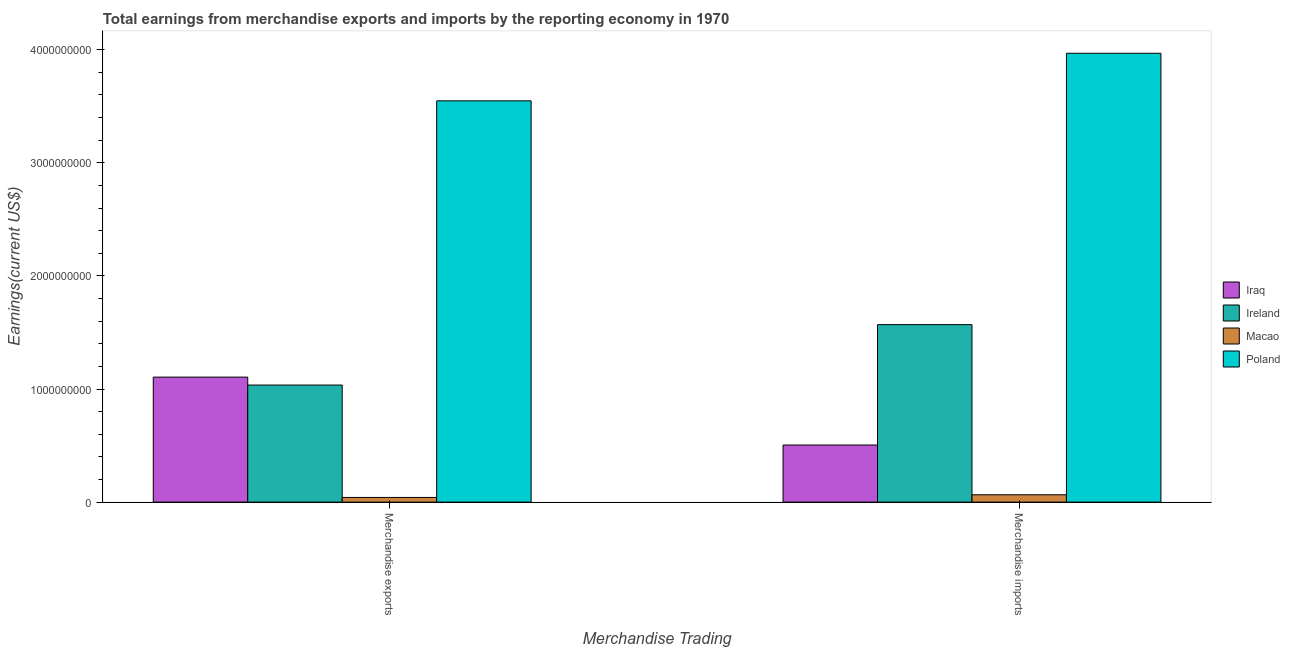How many different coloured bars are there?
Your answer should be compact. 4. How many groups of bars are there?
Ensure brevity in your answer.  2. Are the number of bars per tick equal to the number of legend labels?
Your response must be concise. Yes. Are the number of bars on each tick of the X-axis equal?
Make the answer very short. Yes. How many bars are there on the 1st tick from the left?
Your response must be concise. 4. What is the label of the 1st group of bars from the left?
Keep it short and to the point. Merchandise exports. What is the earnings from merchandise imports in Iraq?
Give a very brief answer. 5.05e+08. Across all countries, what is the maximum earnings from merchandise exports?
Your response must be concise. 3.55e+09. Across all countries, what is the minimum earnings from merchandise imports?
Provide a short and direct response. 6.50e+07. In which country was the earnings from merchandise imports maximum?
Make the answer very short. Poland. In which country was the earnings from merchandise imports minimum?
Give a very brief answer. Macao. What is the total earnings from merchandise imports in the graph?
Your answer should be compact. 6.11e+09. What is the difference between the earnings from merchandise imports in Ireland and that in Iraq?
Provide a short and direct response. 1.06e+09. What is the difference between the earnings from merchandise imports in Iraq and the earnings from merchandise exports in Poland?
Make the answer very short. -3.04e+09. What is the average earnings from merchandise exports per country?
Your answer should be very brief. 1.43e+09. What is the difference between the earnings from merchandise imports and earnings from merchandise exports in Poland?
Give a very brief answer. 4.21e+08. What is the ratio of the earnings from merchandise imports in Poland to that in Ireland?
Offer a terse response. 2.53. Is the earnings from merchandise imports in Macao less than that in Poland?
Keep it short and to the point. Yes. What does the 3rd bar from the left in Merchandise exports represents?
Make the answer very short. Macao. What does the 1st bar from the right in Merchandise exports represents?
Provide a succinct answer. Poland. How many bars are there?
Make the answer very short. 8. Are all the bars in the graph horizontal?
Offer a very short reply. No. How many countries are there in the graph?
Make the answer very short. 4. What is the difference between two consecutive major ticks on the Y-axis?
Offer a very short reply. 1.00e+09. Where does the legend appear in the graph?
Offer a terse response. Center right. How are the legend labels stacked?
Your answer should be very brief. Vertical. What is the title of the graph?
Your answer should be very brief. Total earnings from merchandise exports and imports by the reporting economy in 1970. Does "Indonesia" appear as one of the legend labels in the graph?
Provide a short and direct response. No. What is the label or title of the X-axis?
Offer a very short reply. Merchandise Trading. What is the label or title of the Y-axis?
Give a very brief answer. Earnings(current US$). What is the Earnings(current US$) in Iraq in Merchandise exports?
Provide a short and direct response. 1.11e+09. What is the Earnings(current US$) in Ireland in Merchandise exports?
Your response must be concise. 1.03e+09. What is the Earnings(current US$) of Macao in Merchandise exports?
Your response must be concise. 4.14e+07. What is the Earnings(current US$) of Poland in Merchandise exports?
Provide a short and direct response. 3.55e+09. What is the Earnings(current US$) of Iraq in Merchandise imports?
Your answer should be very brief. 5.05e+08. What is the Earnings(current US$) of Ireland in Merchandise imports?
Provide a succinct answer. 1.57e+09. What is the Earnings(current US$) of Macao in Merchandise imports?
Ensure brevity in your answer.  6.50e+07. What is the Earnings(current US$) in Poland in Merchandise imports?
Offer a very short reply. 3.97e+09. Across all Merchandise Trading, what is the maximum Earnings(current US$) in Iraq?
Provide a succinct answer. 1.11e+09. Across all Merchandise Trading, what is the maximum Earnings(current US$) in Ireland?
Provide a short and direct response. 1.57e+09. Across all Merchandise Trading, what is the maximum Earnings(current US$) in Macao?
Offer a terse response. 6.50e+07. Across all Merchandise Trading, what is the maximum Earnings(current US$) in Poland?
Provide a succinct answer. 3.97e+09. Across all Merchandise Trading, what is the minimum Earnings(current US$) in Iraq?
Give a very brief answer. 5.05e+08. Across all Merchandise Trading, what is the minimum Earnings(current US$) of Ireland?
Your answer should be very brief. 1.03e+09. Across all Merchandise Trading, what is the minimum Earnings(current US$) in Macao?
Offer a terse response. 4.14e+07. Across all Merchandise Trading, what is the minimum Earnings(current US$) of Poland?
Offer a very short reply. 3.55e+09. What is the total Earnings(current US$) of Iraq in the graph?
Your answer should be very brief. 1.61e+09. What is the total Earnings(current US$) of Ireland in the graph?
Provide a succinct answer. 2.60e+09. What is the total Earnings(current US$) in Macao in the graph?
Make the answer very short. 1.06e+08. What is the total Earnings(current US$) of Poland in the graph?
Offer a very short reply. 7.52e+09. What is the difference between the Earnings(current US$) in Iraq in Merchandise exports and that in Merchandise imports?
Offer a terse response. 6.00e+08. What is the difference between the Earnings(current US$) of Ireland in Merchandise exports and that in Merchandise imports?
Give a very brief answer. -5.34e+08. What is the difference between the Earnings(current US$) of Macao in Merchandise exports and that in Merchandise imports?
Give a very brief answer. -2.36e+07. What is the difference between the Earnings(current US$) of Poland in Merchandise exports and that in Merchandise imports?
Give a very brief answer. -4.21e+08. What is the difference between the Earnings(current US$) in Iraq in Merchandise exports and the Earnings(current US$) in Ireland in Merchandise imports?
Your response must be concise. -4.64e+08. What is the difference between the Earnings(current US$) of Iraq in Merchandise exports and the Earnings(current US$) of Macao in Merchandise imports?
Provide a short and direct response. 1.04e+09. What is the difference between the Earnings(current US$) of Iraq in Merchandise exports and the Earnings(current US$) of Poland in Merchandise imports?
Your response must be concise. -2.86e+09. What is the difference between the Earnings(current US$) of Ireland in Merchandise exports and the Earnings(current US$) of Macao in Merchandise imports?
Provide a short and direct response. 9.70e+08. What is the difference between the Earnings(current US$) of Ireland in Merchandise exports and the Earnings(current US$) of Poland in Merchandise imports?
Ensure brevity in your answer.  -2.93e+09. What is the difference between the Earnings(current US$) of Macao in Merchandise exports and the Earnings(current US$) of Poland in Merchandise imports?
Provide a succinct answer. -3.93e+09. What is the average Earnings(current US$) of Iraq per Merchandise Trading?
Your answer should be very brief. 8.05e+08. What is the average Earnings(current US$) in Ireland per Merchandise Trading?
Provide a succinct answer. 1.30e+09. What is the average Earnings(current US$) in Macao per Merchandise Trading?
Your response must be concise. 5.32e+07. What is the average Earnings(current US$) of Poland per Merchandise Trading?
Make the answer very short. 3.76e+09. What is the difference between the Earnings(current US$) in Iraq and Earnings(current US$) in Ireland in Merchandise exports?
Your response must be concise. 7.02e+07. What is the difference between the Earnings(current US$) in Iraq and Earnings(current US$) in Macao in Merchandise exports?
Provide a short and direct response. 1.06e+09. What is the difference between the Earnings(current US$) of Iraq and Earnings(current US$) of Poland in Merchandise exports?
Your answer should be compact. -2.44e+09. What is the difference between the Earnings(current US$) of Ireland and Earnings(current US$) of Macao in Merchandise exports?
Ensure brevity in your answer.  9.94e+08. What is the difference between the Earnings(current US$) in Ireland and Earnings(current US$) in Poland in Merchandise exports?
Make the answer very short. -2.51e+09. What is the difference between the Earnings(current US$) in Macao and Earnings(current US$) in Poland in Merchandise exports?
Ensure brevity in your answer.  -3.51e+09. What is the difference between the Earnings(current US$) in Iraq and Earnings(current US$) in Ireland in Merchandise imports?
Your response must be concise. -1.06e+09. What is the difference between the Earnings(current US$) of Iraq and Earnings(current US$) of Macao in Merchandise imports?
Keep it short and to the point. 4.40e+08. What is the difference between the Earnings(current US$) of Iraq and Earnings(current US$) of Poland in Merchandise imports?
Offer a very short reply. -3.46e+09. What is the difference between the Earnings(current US$) in Ireland and Earnings(current US$) in Macao in Merchandise imports?
Make the answer very short. 1.50e+09. What is the difference between the Earnings(current US$) of Ireland and Earnings(current US$) of Poland in Merchandise imports?
Offer a very short reply. -2.40e+09. What is the difference between the Earnings(current US$) in Macao and Earnings(current US$) in Poland in Merchandise imports?
Provide a succinct answer. -3.90e+09. What is the ratio of the Earnings(current US$) in Iraq in Merchandise exports to that in Merchandise imports?
Offer a terse response. 2.19. What is the ratio of the Earnings(current US$) of Ireland in Merchandise exports to that in Merchandise imports?
Keep it short and to the point. 0.66. What is the ratio of the Earnings(current US$) in Macao in Merchandise exports to that in Merchandise imports?
Keep it short and to the point. 0.64. What is the ratio of the Earnings(current US$) of Poland in Merchandise exports to that in Merchandise imports?
Ensure brevity in your answer.  0.89. What is the difference between the highest and the second highest Earnings(current US$) of Iraq?
Your response must be concise. 6.00e+08. What is the difference between the highest and the second highest Earnings(current US$) of Ireland?
Your answer should be compact. 5.34e+08. What is the difference between the highest and the second highest Earnings(current US$) in Macao?
Give a very brief answer. 2.36e+07. What is the difference between the highest and the second highest Earnings(current US$) in Poland?
Offer a terse response. 4.21e+08. What is the difference between the highest and the lowest Earnings(current US$) of Iraq?
Give a very brief answer. 6.00e+08. What is the difference between the highest and the lowest Earnings(current US$) in Ireland?
Ensure brevity in your answer.  5.34e+08. What is the difference between the highest and the lowest Earnings(current US$) in Macao?
Offer a very short reply. 2.36e+07. What is the difference between the highest and the lowest Earnings(current US$) of Poland?
Provide a succinct answer. 4.21e+08. 